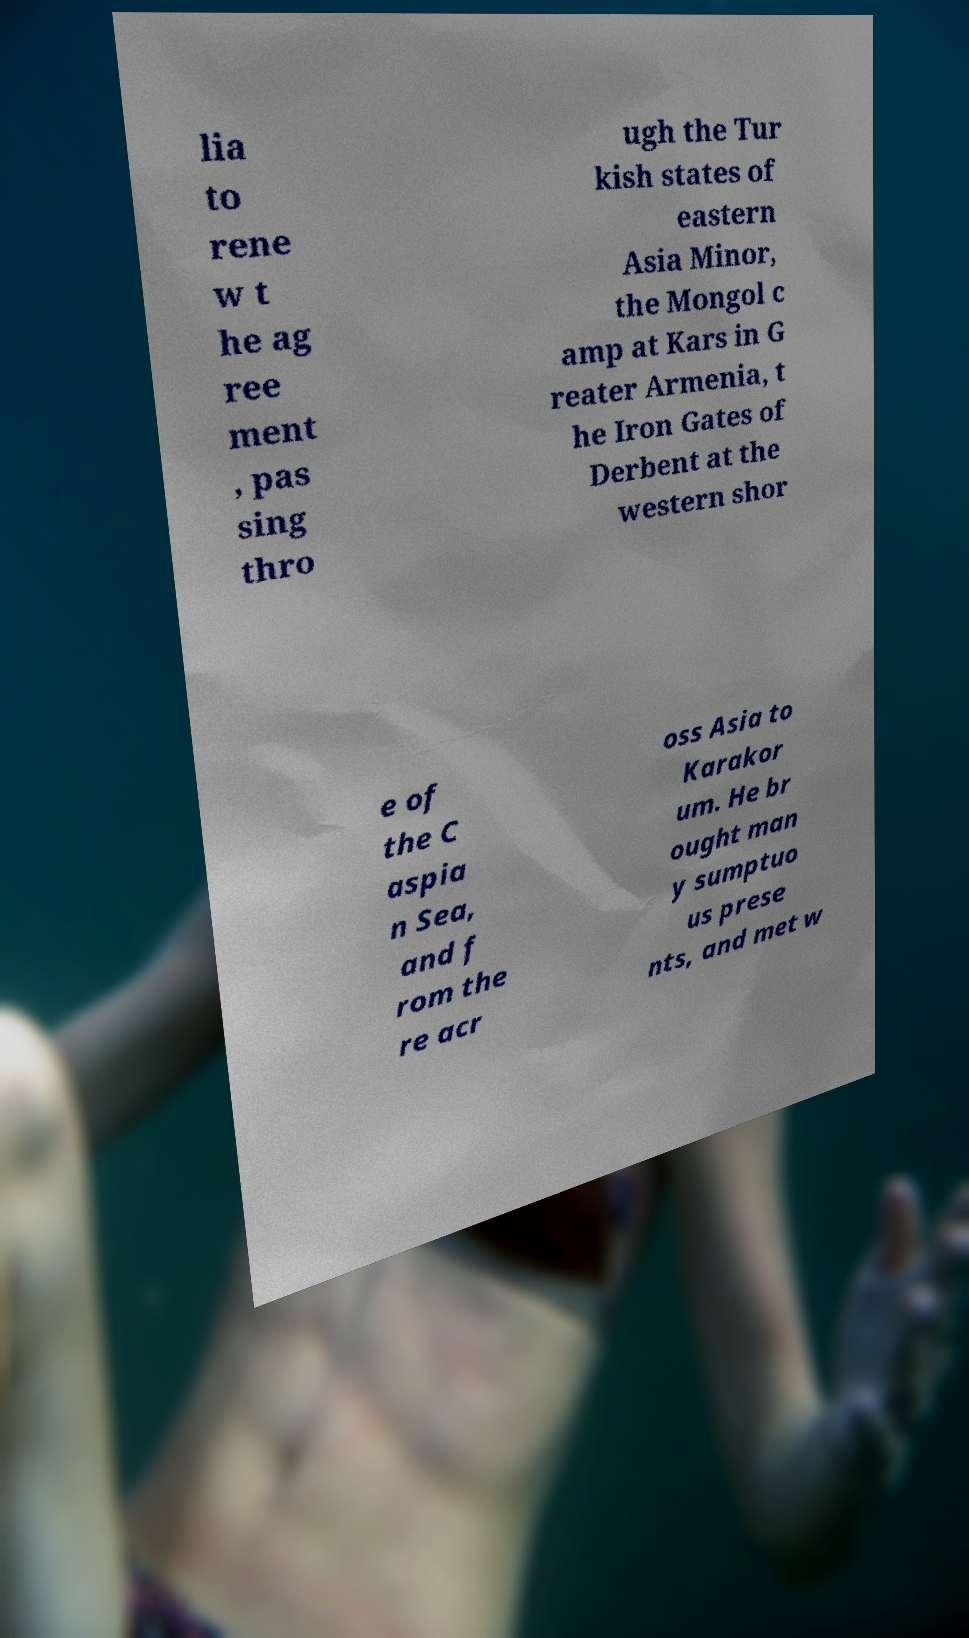What messages or text are displayed in this image? I need them in a readable, typed format. lia to rene w t he ag ree ment , pas sing thro ugh the Tur kish states of eastern Asia Minor, the Mongol c amp at Kars in G reater Armenia, t he Iron Gates of Derbent at the western shor e of the C aspia n Sea, and f rom the re acr oss Asia to Karakor um. He br ought man y sumptuo us prese nts, and met w 